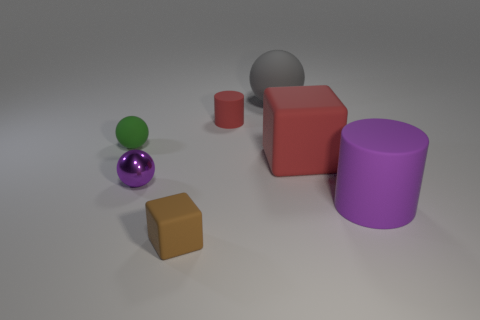There is a large object in front of the cube to the right of the red thing to the left of the gray rubber sphere; what is it made of?
Give a very brief answer. Rubber. Is the shape of the brown rubber object the same as the big purple object?
Give a very brief answer. No. Is there any other thing that has the same material as the small purple sphere?
Offer a terse response. No. What number of cubes are both left of the large red cube and to the right of the tiny red rubber object?
Your answer should be compact. 0. The matte cylinder behind the large rubber thing in front of the tiny purple ball is what color?
Provide a succinct answer. Red. Are there the same number of small cylinders on the right side of the large cylinder and large green shiny things?
Your answer should be very brief. Yes. How many blocks are in front of the rubber cylinder in front of the tiny object that is to the left of the purple metallic sphere?
Provide a short and direct response. 1. What color is the rubber cylinder on the left side of the purple rubber thing?
Your answer should be very brief. Red. There is a object that is both left of the small red cylinder and behind the small purple metallic sphere; what material is it?
Provide a succinct answer. Rubber. There is a cylinder to the right of the big gray thing; what number of big objects are behind it?
Your response must be concise. 2. 